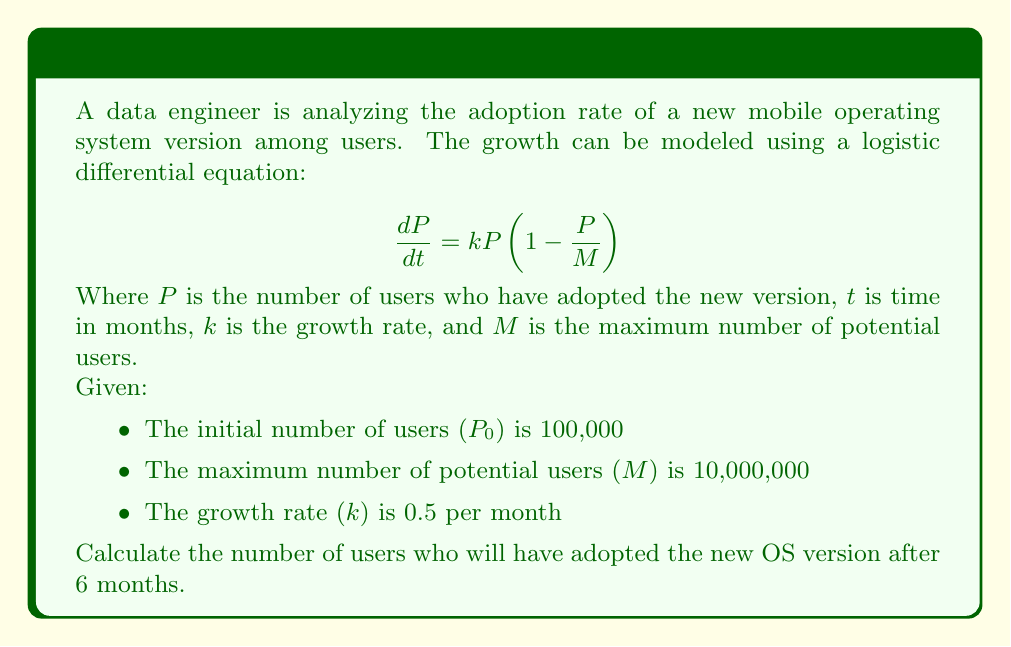Solve this math problem. To solve this problem, we need to use the solution to the logistic differential equation, which is:

$$P(t) = \frac{M}{1 + (\frac{M}{P_0} - 1)e^{-kt}}$$

Let's break down the solution step-by-step:

1. Identify the given values:
   $P_0 = 100,000$
   $M = 10,000,000$
   $k = 0.5$
   $t = 6$ months

2. Substitute these values into the equation:

   $$P(6) = \frac{10,000,000}{1 + (\frac{10,000,000}{100,000} - 1)e^{-0.5 \cdot 6}}$$

3. Simplify the fraction inside the parentheses:

   $$P(6) = \frac{10,000,000}{1 + (100 - 1)e^{-3}}$$

4. Evaluate $e^{-3}$:
   $e^{-3} \approx 0.0497$

5. Multiply $(100 - 1)$ by $e^{-3}$:
   $99 \cdot 0.0497 \approx 4.9203$

6. Add 1 to the result:
   $1 + 4.9203 = 5.9203$

7. Divide 10,000,000 by this result:

   $$P(6) = \frac{10,000,000}{5.9203} \approx 1,688,275.93$$

8. Round to the nearest whole number, as we're dealing with users:

   $P(6) \approx 1,688,276$ users
Answer: After 6 months, approximately 1,688,276 users will have adopted the new OS version. 